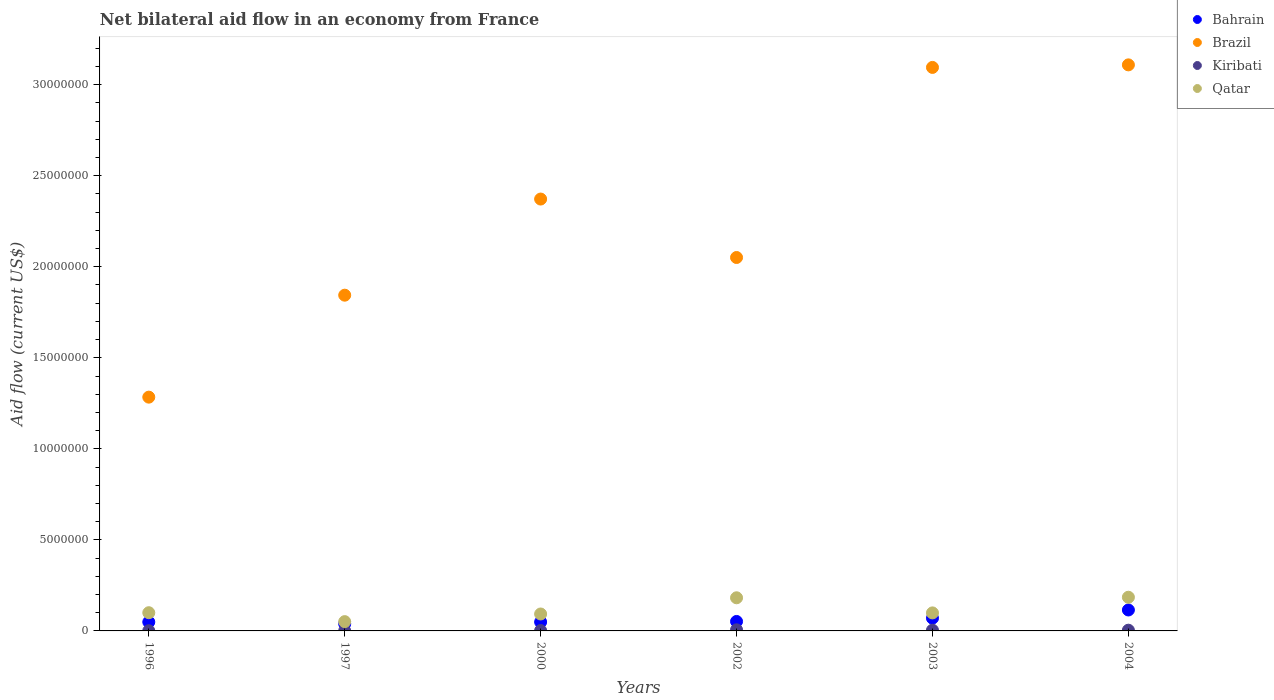Is the number of dotlines equal to the number of legend labels?
Provide a succinct answer. Yes. What is the net bilateral aid flow in Brazil in 2002?
Provide a succinct answer. 2.05e+07. Across all years, what is the maximum net bilateral aid flow in Brazil?
Provide a succinct answer. 3.11e+07. Across all years, what is the minimum net bilateral aid flow in Brazil?
Provide a short and direct response. 1.28e+07. What is the total net bilateral aid flow in Qatar in the graph?
Make the answer very short. 7.10e+06. What is the difference between the net bilateral aid flow in Qatar in 2000 and that in 2004?
Provide a succinct answer. -9.20e+05. What is the difference between the net bilateral aid flow in Kiribati in 2003 and the net bilateral aid flow in Qatar in 1997?
Make the answer very short. -4.70e+05. What is the average net bilateral aid flow in Qatar per year?
Your answer should be compact. 1.18e+06. In the year 2002, what is the difference between the net bilateral aid flow in Qatar and net bilateral aid flow in Brazil?
Provide a short and direct response. -1.87e+07. What is the ratio of the net bilateral aid flow in Qatar in 1997 to that in 2000?
Keep it short and to the point. 0.55. Is the difference between the net bilateral aid flow in Qatar in 2003 and 2004 greater than the difference between the net bilateral aid flow in Brazil in 2003 and 2004?
Offer a very short reply. No. What is the difference between the highest and the second highest net bilateral aid flow in Kiribati?
Keep it short and to the point. 2.00e+04. What is the difference between the highest and the lowest net bilateral aid flow in Qatar?
Give a very brief answer. 1.34e+06. Is the sum of the net bilateral aid flow in Brazil in 1997 and 2003 greater than the maximum net bilateral aid flow in Kiribati across all years?
Offer a terse response. Yes. Is it the case that in every year, the sum of the net bilateral aid flow in Qatar and net bilateral aid flow in Kiribati  is greater than the sum of net bilateral aid flow in Brazil and net bilateral aid flow in Bahrain?
Provide a short and direct response. No. Is it the case that in every year, the sum of the net bilateral aid flow in Kiribati and net bilateral aid flow in Qatar  is greater than the net bilateral aid flow in Brazil?
Make the answer very short. No. How many dotlines are there?
Keep it short and to the point. 4. Are the values on the major ticks of Y-axis written in scientific E-notation?
Provide a succinct answer. No. Does the graph contain grids?
Keep it short and to the point. No. What is the title of the graph?
Give a very brief answer. Net bilateral aid flow in an economy from France. Does "Uganda" appear as one of the legend labels in the graph?
Your answer should be compact. No. What is the label or title of the X-axis?
Ensure brevity in your answer.  Years. What is the Aid flow (current US$) of Brazil in 1996?
Offer a terse response. 1.28e+07. What is the Aid flow (current US$) of Kiribati in 1996?
Your answer should be compact. 10000. What is the Aid flow (current US$) in Qatar in 1996?
Make the answer very short. 1.00e+06. What is the Aid flow (current US$) in Bahrain in 1997?
Your answer should be compact. 3.90e+05. What is the Aid flow (current US$) in Brazil in 1997?
Offer a very short reply. 1.84e+07. What is the Aid flow (current US$) of Kiribati in 1997?
Provide a succinct answer. 10000. What is the Aid flow (current US$) of Qatar in 1997?
Make the answer very short. 5.10e+05. What is the Aid flow (current US$) in Brazil in 2000?
Ensure brevity in your answer.  2.37e+07. What is the Aid flow (current US$) of Qatar in 2000?
Your response must be concise. 9.30e+05. What is the Aid flow (current US$) of Bahrain in 2002?
Your response must be concise. 5.20e+05. What is the Aid flow (current US$) of Brazil in 2002?
Give a very brief answer. 2.05e+07. What is the Aid flow (current US$) of Kiribati in 2002?
Give a very brief answer. 6.00e+04. What is the Aid flow (current US$) in Qatar in 2002?
Provide a short and direct response. 1.82e+06. What is the Aid flow (current US$) in Brazil in 2003?
Give a very brief answer. 3.10e+07. What is the Aid flow (current US$) of Qatar in 2003?
Offer a very short reply. 9.90e+05. What is the Aid flow (current US$) of Bahrain in 2004?
Ensure brevity in your answer.  1.15e+06. What is the Aid flow (current US$) in Brazil in 2004?
Provide a short and direct response. 3.11e+07. What is the Aid flow (current US$) in Qatar in 2004?
Make the answer very short. 1.85e+06. Across all years, what is the maximum Aid flow (current US$) of Bahrain?
Keep it short and to the point. 1.15e+06. Across all years, what is the maximum Aid flow (current US$) of Brazil?
Provide a short and direct response. 3.11e+07. Across all years, what is the maximum Aid flow (current US$) of Qatar?
Your answer should be compact. 1.85e+06. Across all years, what is the minimum Aid flow (current US$) of Brazil?
Provide a short and direct response. 1.28e+07. Across all years, what is the minimum Aid flow (current US$) of Qatar?
Ensure brevity in your answer.  5.10e+05. What is the total Aid flow (current US$) in Bahrain in the graph?
Offer a very short reply. 3.74e+06. What is the total Aid flow (current US$) of Brazil in the graph?
Your answer should be compact. 1.38e+08. What is the total Aid flow (current US$) in Qatar in the graph?
Ensure brevity in your answer.  7.10e+06. What is the difference between the Aid flow (current US$) of Brazil in 1996 and that in 1997?
Offer a very short reply. -5.60e+06. What is the difference between the Aid flow (current US$) in Qatar in 1996 and that in 1997?
Make the answer very short. 4.90e+05. What is the difference between the Aid flow (current US$) of Bahrain in 1996 and that in 2000?
Offer a very short reply. 0. What is the difference between the Aid flow (current US$) in Brazil in 1996 and that in 2000?
Your answer should be very brief. -1.09e+07. What is the difference between the Aid flow (current US$) in Bahrain in 1996 and that in 2002?
Your answer should be very brief. -3.00e+04. What is the difference between the Aid flow (current US$) of Brazil in 1996 and that in 2002?
Provide a succinct answer. -7.67e+06. What is the difference between the Aid flow (current US$) in Qatar in 1996 and that in 2002?
Offer a terse response. -8.20e+05. What is the difference between the Aid flow (current US$) of Bahrain in 1996 and that in 2003?
Ensure brevity in your answer.  -2.10e+05. What is the difference between the Aid flow (current US$) in Brazil in 1996 and that in 2003?
Your answer should be very brief. -1.81e+07. What is the difference between the Aid flow (current US$) in Kiribati in 1996 and that in 2003?
Offer a terse response. -3.00e+04. What is the difference between the Aid flow (current US$) in Bahrain in 1996 and that in 2004?
Your answer should be compact. -6.60e+05. What is the difference between the Aid flow (current US$) of Brazil in 1996 and that in 2004?
Your answer should be compact. -1.82e+07. What is the difference between the Aid flow (current US$) of Kiribati in 1996 and that in 2004?
Ensure brevity in your answer.  -3.00e+04. What is the difference between the Aid flow (current US$) in Qatar in 1996 and that in 2004?
Your response must be concise. -8.50e+05. What is the difference between the Aid flow (current US$) of Bahrain in 1997 and that in 2000?
Keep it short and to the point. -1.00e+05. What is the difference between the Aid flow (current US$) of Brazil in 1997 and that in 2000?
Give a very brief answer. -5.28e+06. What is the difference between the Aid flow (current US$) in Qatar in 1997 and that in 2000?
Provide a short and direct response. -4.20e+05. What is the difference between the Aid flow (current US$) of Bahrain in 1997 and that in 2002?
Give a very brief answer. -1.30e+05. What is the difference between the Aid flow (current US$) of Brazil in 1997 and that in 2002?
Your answer should be very brief. -2.07e+06. What is the difference between the Aid flow (current US$) in Kiribati in 1997 and that in 2002?
Ensure brevity in your answer.  -5.00e+04. What is the difference between the Aid flow (current US$) in Qatar in 1997 and that in 2002?
Provide a short and direct response. -1.31e+06. What is the difference between the Aid flow (current US$) of Bahrain in 1997 and that in 2003?
Give a very brief answer. -3.10e+05. What is the difference between the Aid flow (current US$) in Brazil in 1997 and that in 2003?
Your answer should be compact. -1.25e+07. What is the difference between the Aid flow (current US$) in Qatar in 1997 and that in 2003?
Give a very brief answer. -4.80e+05. What is the difference between the Aid flow (current US$) of Bahrain in 1997 and that in 2004?
Make the answer very short. -7.60e+05. What is the difference between the Aid flow (current US$) in Brazil in 1997 and that in 2004?
Offer a very short reply. -1.26e+07. What is the difference between the Aid flow (current US$) of Kiribati in 1997 and that in 2004?
Give a very brief answer. -3.00e+04. What is the difference between the Aid flow (current US$) of Qatar in 1997 and that in 2004?
Offer a terse response. -1.34e+06. What is the difference between the Aid flow (current US$) of Brazil in 2000 and that in 2002?
Your answer should be compact. 3.21e+06. What is the difference between the Aid flow (current US$) in Kiribati in 2000 and that in 2002?
Ensure brevity in your answer.  -4.00e+04. What is the difference between the Aid flow (current US$) in Qatar in 2000 and that in 2002?
Offer a terse response. -8.90e+05. What is the difference between the Aid flow (current US$) of Brazil in 2000 and that in 2003?
Provide a succinct answer. -7.23e+06. What is the difference between the Aid flow (current US$) of Qatar in 2000 and that in 2003?
Keep it short and to the point. -6.00e+04. What is the difference between the Aid flow (current US$) of Bahrain in 2000 and that in 2004?
Provide a succinct answer. -6.60e+05. What is the difference between the Aid flow (current US$) in Brazil in 2000 and that in 2004?
Keep it short and to the point. -7.37e+06. What is the difference between the Aid flow (current US$) in Qatar in 2000 and that in 2004?
Provide a short and direct response. -9.20e+05. What is the difference between the Aid flow (current US$) in Brazil in 2002 and that in 2003?
Ensure brevity in your answer.  -1.04e+07. What is the difference between the Aid flow (current US$) of Qatar in 2002 and that in 2003?
Your answer should be very brief. 8.30e+05. What is the difference between the Aid flow (current US$) of Bahrain in 2002 and that in 2004?
Keep it short and to the point. -6.30e+05. What is the difference between the Aid flow (current US$) in Brazil in 2002 and that in 2004?
Make the answer very short. -1.06e+07. What is the difference between the Aid flow (current US$) of Kiribati in 2002 and that in 2004?
Provide a short and direct response. 2.00e+04. What is the difference between the Aid flow (current US$) of Bahrain in 2003 and that in 2004?
Your response must be concise. -4.50e+05. What is the difference between the Aid flow (current US$) of Brazil in 2003 and that in 2004?
Give a very brief answer. -1.40e+05. What is the difference between the Aid flow (current US$) of Kiribati in 2003 and that in 2004?
Keep it short and to the point. 0. What is the difference between the Aid flow (current US$) of Qatar in 2003 and that in 2004?
Make the answer very short. -8.60e+05. What is the difference between the Aid flow (current US$) in Bahrain in 1996 and the Aid flow (current US$) in Brazil in 1997?
Your response must be concise. -1.80e+07. What is the difference between the Aid flow (current US$) in Bahrain in 1996 and the Aid flow (current US$) in Qatar in 1997?
Ensure brevity in your answer.  -2.00e+04. What is the difference between the Aid flow (current US$) in Brazil in 1996 and the Aid flow (current US$) in Kiribati in 1997?
Offer a very short reply. 1.28e+07. What is the difference between the Aid flow (current US$) in Brazil in 1996 and the Aid flow (current US$) in Qatar in 1997?
Your response must be concise. 1.23e+07. What is the difference between the Aid flow (current US$) in Kiribati in 1996 and the Aid flow (current US$) in Qatar in 1997?
Give a very brief answer. -5.00e+05. What is the difference between the Aid flow (current US$) of Bahrain in 1996 and the Aid flow (current US$) of Brazil in 2000?
Give a very brief answer. -2.32e+07. What is the difference between the Aid flow (current US$) of Bahrain in 1996 and the Aid flow (current US$) of Kiribati in 2000?
Offer a terse response. 4.70e+05. What is the difference between the Aid flow (current US$) of Bahrain in 1996 and the Aid flow (current US$) of Qatar in 2000?
Your answer should be very brief. -4.40e+05. What is the difference between the Aid flow (current US$) of Brazil in 1996 and the Aid flow (current US$) of Kiribati in 2000?
Your answer should be compact. 1.28e+07. What is the difference between the Aid flow (current US$) of Brazil in 1996 and the Aid flow (current US$) of Qatar in 2000?
Offer a very short reply. 1.19e+07. What is the difference between the Aid flow (current US$) of Kiribati in 1996 and the Aid flow (current US$) of Qatar in 2000?
Provide a short and direct response. -9.20e+05. What is the difference between the Aid flow (current US$) in Bahrain in 1996 and the Aid flow (current US$) in Brazil in 2002?
Ensure brevity in your answer.  -2.00e+07. What is the difference between the Aid flow (current US$) of Bahrain in 1996 and the Aid flow (current US$) of Kiribati in 2002?
Provide a succinct answer. 4.30e+05. What is the difference between the Aid flow (current US$) of Bahrain in 1996 and the Aid flow (current US$) of Qatar in 2002?
Give a very brief answer. -1.33e+06. What is the difference between the Aid flow (current US$) in Brazil in 1996 and the Aid flow (current US$) in Kiribati in 2002?
Offer a very short reply. 1.28e+07. What is the difference between the Aid flow (current US$) of Brazil in 1996 and the Aid flow (current US$) of Qatar in 2002?
Keep it short and to the point. 1.10e+07. What is the difference between the Aid flow (current US$) of Kiribati in 1996 and the Aid flow (current US$) of Qatar in 2002?
Ensure brevity in your answer.  -1.81e+06. What is the difference between the Aid flow (current US$) of Bahrain in 1996 and the Aid flow (current US$) of Brazil in 2003?
Make the answer very short. -3.05e+07. What is the difference between the Aid flow (current US$) of Bahrain in 1996 and the Aid flow (current US$) of Qatar in 2003?
Offer a terse response. -5.00e+05. What is the difference between the Aid flow (current US$) in Brazil in 1996 and the Aid flow (current US$) in Kiribati in 2003?
Your response must be concise. 1.28e+07. What is the difference between the Aid flow (current US$) in Brazil in 1996 and the Aid flow (current US$) in Qatar in 2003?
Provide a short and direct response. 1.18e+07. What is the difference between the Aid flow (current US$) of Kiribati in 1996 and the Aid flow (current US$) of Qatar in 2003?
Ensure brevity in your answer.  -9.80e+05. What is the difference between the Aid flow (current US$) in Bahrain in 1996 and the Aid flow (current US$) in Brazil in 2004?
Your response must be concise. -3.06e+07. What is the difference between the Aid flow (current US$) in Bahrain in 1996 and the Aid flow (current US$) in Qatar in 2004?
Provide a short and direct response. -1.36e+06. What is the difference between the Aid flow (current US$) in Brazil in 1996 and the Aid flow (current US$) in Kiribati in 2004?
Your answer should be compact. 1.28e+07. What is the difference between the Aid flow (current US$) of Brazil in 1996 and the Aid flow (current US$) of Qatar in 2004?
Ensure brevity in your answer.  1.10e+07. What is the difference between the Aid flow (current US$) of Kiribati in 1996 and the Aid flow (current US$) of Qatar in 2004?
Offer a very short reply. -1.84e+06. What is the difference between the Aid flow (current US$) in Bahrain in 1997 and the Aid flow (current US$) in Brazil in 2000?
Your answer should be very brief. -2.33e+07. What is the difference between the Aid flow (current US$) of Bahrain in 1997 and the Aid flow (current US$) of Qatar in 2000?
Make the answer very short. -5.40e+05. What is the difference between the Aid flow (current US$) in Brazil in 1997 and the Aid flow (current US$) in Kiribati in 2000?
Your answer should be compact. 1.84e+07. What is the difference between the Aid flow (current US$) in Brazil in 1997 and the Aid flow (current US$) in Qatar in 2000?
Make the answer very short. 1.75e+07. What is the difference between the Aid flow (current US$) of Kiribati in 1997 and the Aid flow (current US$) of Qatar in 2000?
Make the answer very short. -9.20e+05. What is the difference between the Aid flow (current US$) of Bahrain in 1997 and the Aid flow (current US$) of Brazil in 2002?
Provide a short and direct response. -2.01e+07. What is the difference between the Aid flow (current US$) of Bahrain in 1997 and the Aid flow (current US$) of Qatar in 2002?
Keep it short and to the point. -1.43e+06. What is the difference between the Aid flow (current US$) of Brazil in 1997 and the Aid flow (current US$) of Kiribati in 2002?
Keep it short and to the point. 1.84e+07. What is the difference between the Aid flow (current US$) of Brazil in 1997 and the Aid flow (current US$) of Qatar in 2002?
Make the answer very short. 1.66e+07. What is the difference between the Aid flow (current US$) in Kiribati in 1997 and the Aid flow (current US$) in Qatar in 2002?
Provide a short and direct response. -1.81e+06. What is the difference between the Aid flow (current US$) of Bahrain in 1997 and the Aid flow (current US$) of Brazil in 2003?
Provide a short and direct response. -3.06e+07. What is the difference between the Aid flow (current US$) in Bahrain in 1997 and the Aid flow (current US$) in Kiribati in 2003?
Your answer should be very brief. 3.50e+05. What is the difference between the Aid flow (current US$) of Bahrain in 1997 and the Aid flow (current US$) of Qatar in 2003?
Provide a short and direct response. -6.00e+05. What is the difference between the Aid flow (current US$) of Brazil in 1997 and the Aid flow (current US$) of Kiribati in 2003?
Give a very brief answer. 1.84e+07. What is the difference between the Aid flow (current US$) in Brazil in 1997 and the Aid flow (current US$) in Qatar in 2003?
Provide a short and direct response. 1.74e+07. What is the difference between the Aid flow (current US$) of Kiribati in 1997 and the Aid flow (current US$) of Qatar in 2003?
Your answer should be very brief. -9.80e+05. What is the difference between the Aid flow (current US$) in Bahrain in 1997 and the Aid flow (current US$) in Brazil in 2004?
Offer a very short reply. -3.07e+07. What is the difference between the Aid flow (current US$) of Bahrain in 1997 and the Aid flow (current US$) of Qatar in 2004?
Make the answer very short. -1.46e+06. What is the difference between the Aid flow (current US$) of Brazil in 1997 and the Aid flow (current US$) of Kiribati in 2004?
Give a very brief answer. 1.84e+07. What is the difference between the Aid flow (current US$) in Brazil in 1997 and the Aid flow (current US$) in Qatar in 2004?
Provide a short and direct response. 1.66e+07. What is the difference between the Aid flow (current US$) in Kiribati in 1997 and the Aid flow (current US$) in Qatar in 2004?
Your answer should be very brief. -1.84e+06. What is the difference between the Aid flow (current US$) in Bahrain in 2000 and the Aid flow (current US$) in Brazil in 2002?
Give a very brief answer. -2.00e+07. What is the difference between the Aid flow (current US$) in Bahrain in 2000 and the Aid flow (current US$) in Kiribati in 2002?
Provide a short and direct response. 4.30e+05. What is the difference between the Aid flow (current US$) in Bahrain in 2000 and the Aid flow (current US$) in Qatar in 2002?
Offer a terse response. -1.33e+06. What is the difference between the Aid flow (current US$) of Brazil in 2000 and the Aid flow (current US$) of Kiribati in 2002?
Your answer should be compact. 2.37e+07. What is the difference between the Aid flow (current US$) of Brazil in 2000 and the Aid flow (current US$) of Qatar in 2002?
Your answer should be compact. 2.19e+07. What is the difference between the Aid flow (current US$) of Kiribati in 2000 and the Aid flow (current US$) of Qatar in 2002?
Ensure brevity in your answer.  -1.80e+06. What is the difference between the Aid flow (current US$) in Bahrain in 2000 and the Aid flow (current US$) in Brazil in 2003?
Give a very brief answer. -3.05e+07. What is the difference between the Aid flow (current US$) of Bahrain in 2000 and the Aid flow (current US$) of Kiribati in 2003?
Provide a short and direct response. 4.50e+05. What is the difference between the Aid flow (current US$) in Bahrain in 2000 and the Aid flow (current US$) in Qatar in 2003?
Offer a terse response. -5.00e+05. What is the difference between the Aid flow (current US$) of Brazil in 2000 and the Aid flow (current US$) of Kiribati in 2003?
Keep it short and to the point. 2.37e+07. What is the difference between the Aid flow (current US$) in Brazil in 2000 and the Aid flow (current US$) in Qatar in 2003?
Ensure brevity in your answer.  2.27e+07. What is the difference between the Aid flow (current US$) in Kiribati in 2000 and the Aid flow (current US$) in Qatar in 2003?
Your answer should be compact. -9.70e+05. What is the difference between the Aid flow (current US$) in Bahrain in 2000 and the Aid flow (current US$) in Brazil in 2004?
Provide a short and direct response. -3.06e+07. What is the difference between the Aid flow (current US$) of Bahrain in 2000 and the Aid flow (current US$) of Qatar in 2004?
Your answer should be compact. -1.36e+06. What is the difference between the Aid flow (current US$) of Brazil in 2000 and the Aid flow (current US$) of Kiribati in 2004?
Offer a terse response. 2.37e+07. What is the difference between the Aid flow (current US$) in Brazil in 2000 and the Aid flow (current US$) in Qatar in 2004?
Your response must be concise. 2.19e+07. What is the difference between the Aid flow (current US$) of Kiribati in 2000 and the Aid flow (current US$) of Qatar in 2004?
Your answer should be very brief. -1.83e+06. What is the difference between the Aid flow (current US$) of Bahrain in 2002 and the Aid flow (current US$) of Brazil in 2003?
Provide a short and direct response. -3.04e+07. What is the difference between the Aid flow (current US$) of Bahrain in 2002 and the Aid flow (current US$) of Qatar in 2003?
Provide a succinct answer. -4.70e+05. What is the difference between the Aid flow (current US$) of Brazil in 2002 and the Aid flow (current US$) of Kiribati in 2003?
Offer a very short reply. 2.05e+07. What is the difference between the Aid flow (current US$) of Brazil in 2002 and the Aid flow (current US$) of Qatar in 2003?
Keep it short and to the point. 1.95e+07. What is the difference between the Aid flow (current US$) in Kiribati in 2002 and the Aid flow (current US$) in Qatar in 2003?
Offer a very short reply. -9.30e+05. What is the difference between the Aid flow (current US$) of Bahrain in 2002 and the Aid flow (current US$) of Brazil in 2004?
Keep it short and to the point. -3.06e+07. What is the difference between the Aid flow (current US$) of Bahrain in 2002 and the Aid flow (current US$) of Qatar in 2004?
Provide a short and direct response. -1.33e+06. What is the difference between the Aid flow (current US$) in Brazil in 2002 and the Aid flow (current US$) in Kiribati in 2004?
Your answer should be very brief. 2.05e+07. What is the difference between the Aid flow (current US$) in Brazil in 2002 and the Aid flow (current US$) in Qatar in 2004?
Offer a terse response. 1.87e+07. What is the difference between the Aid flow (current US$) of Kiribati in 2002 and the Aid flow (current US$) of Qatar in 2004?
Offer a terse response. -1.79e+06. What is the difference between the Aid flow (current US$) of Bahrain in 2003 and the Aid flow (current US$) of Brazil in 2004?
Your response must be concise. -3.04e+07. What is the difference between the Aid flow (current US$) in Bahrain in 2003 and the Aid flow (current US$) in Kiribati in 2004?
Give a very brief answer. 6.60e+05. What is the difference between the Aid flow (current US$) in Bahrain in 2003 and the Aid flow (current US$) in Qatar in 2004?
Ensure brevity in your answer.  -1.15e+06. What is the difference between the Aid flow (current US$) of Brazil in 2003 and the Aid flow (current US$) of Kiribati in 2004?
Your answer should be compact. 3.09e+07. What is the difference between the Aid flow (current US$) of Brazil in 2003 and the Aid flow (current US$) of Qatar in 2004?
Give a very brief answer. 2.91e+07. What is the difference between the Aid flow (current US$) in Kiribati in 2003 and the Aid flow (current US$) in Qatar in 2004?
Make the answer very short. -1.81e+06. What is the average Aid flow (current US$) in Bahrain per year?
Your answer should be compact. 6.23e+05. What is the average Aid flow (current US$) in Brazil per year?
Provide a short and direct response. 2.29e+07. What is the average Aid flow (current US$) in Qatar per year?
Ensure brevity in your answer.  1.18e+06. In the year 1996, what is the difference between the Aid flow (current US$) in Bahrain and Aid flow (current US$) in Brazil?
Give a very brief answer. -1.24e+07. In the year 1996, what is the difference between the Aid flow (current US$) in Bahrain and Aid flow (current US$) in Qatar?
Offer a terse response. -5.10e+05. In the year 1996, what is the difference between the Aid flow (current US$) of Brazil and Aid flow (current US$) of Kiribati?
Give a very brief answer. 1.28e+07. In the year 1996, what is the difference between the Aid flow (current US$) in Brazil and Aid flow (current US$) in Qatar?
Your answer should be compact. 1.18e+07. In the year 1996, what is the difference between the Aid flow (current US$) of Kiribati and Aid flow (current US$) of Qatar?
Your response must be concise. -9.90e+05. In the year 1997, what is the difference between the Aid flow (current US$) of Bahrain and Aid flow (current US$) of Brazil?
Give a very brief answer. -1.80e+07. In the year 1997, what is the difference between the Aid flow (current US$) of Bahrain and Aid flow (current US$) of Kiribati?
Give a very brief answer. 3.80e+05. In the year 1997, what is the difference between the Aid flow (current US$) in Brazil and Aid flow (current US$) in Kiribati?
Ensure brevity in your answer.  1.84e+07. In the year 1997, what is the difference between the Aid flow (current US$) in Brazil and Aid flow (current US$) in Qatar?
Provide a succinct answer. 1.79e+07. In the year 1997, what is the difference between the Aid flow (current US$) in Kiribati and Aid flow (current US$) in Qatar?
Make the answer very short. -5.00e+05. In the year 2000, what is the difference between the Aid flow (current US$) in Bahrain and Aid flow (current US$) in Brazil?
Offer a terse response. -2.32e+07. In the year 2000, what is the difference between the Aid flow (current US$) in Bahrain and Aid flow (current US$) in Kiribati?
Make the answer very short. 4.70e+05. In the year 2000, what is the difference between the Aid flow (current US$) in Bahrain and Aid flow (current US$) in Qatar?
Ensure brevity in your answer.  -4.40e+05. In the year 2000, what is the difference between the Aid flow (current US$) in Brazil and Aid flow (current US$) in Kiribati?
Ensure brevity in your answer.  2.37e+07. In the year 2000, what is the difference between the Aid flow (current US$) of Brazil and Aid flow (current US$) of Qatar?
Provide a succinct answer. 2.28e+07. In the year 2000, what is the difference between the Aid flow (current US$) in Kiribati and Aid flow (current US$) in Qatar?
Provide a succinct answer. -9.10e+05. In the year 2002, what is the difference between the Aid flow (current US$) in Bahrain and Aid flow (current US$) in Brazil?
Offer a very short reply. -2.00e+07. In the year 2002, what is the difference between the Aid flow (current US$) in Bahrain and Aid flow (current US$) in Qatar?
Ensure brevity in your answer.  -1.30e+06. In the year 2002, what is the difference between the Aid flow (current US$) of Brazil and Aid flow (current US$) of Kiribati?
Make the answer very short. 2.04e+07. In the year 2002, what is the difference between the Aid flow (current US$) of Brazil and Aid flow (current US$) of Qatar?
Provide a succinct answer. 1.87e+07. In the year 2002, what is the difference between the Aid flow (current US$) of Kiribati and Aid flow (current US$) of Qatar?
Offer a terse response. -1.76e+06. In the year 2003, what is the difference between the Aid flow (current US$) in Bahrain and Aid flow (current US$) in Brazil?
Keep it short and to the point. -3.02e+07. In the year 2003, what is the difference between the Aid flow (current US$) in Bahrain and Aid flow (current US$) in Qatar?
Offer a terse response. -2.90e+05. In the year 2003, what is the difference between the Aid flow (current US$) in Brazil and Aid flow (current US$) in Kiribati?
Keep it short and to the point. 3.09e+07. In the year 2003, what is the difference between the Aid flow (current US$) of Brazil and Aid flow (current US$) of Qatar?
Your answer should be very brief. 3.00e+07. In the year 2003, what is the difference between the Aid flow (current US$) in Kiribati and Aid flow (current US$) in Qatar?
Ensure brevity in your answer.  -9.50e+05. In the year 2004, what is the difference between the Aid flow (current US$) in Bahrain and Aid flow (current US$) in Brazil?
Offer a terse response. -2.99e+07. In the year 2004, what is the difference between the Aid flow (current US$) in Bahrain and Aid flow (current US$) in Kiribati?
Ensure brevity in your answer.  1.11e+06. In the year 2004, what is the difference between the Aid flow (current US$) in Bahrain and Aid flow (current US$) in Qatar?
Offer a very short reply. -7.00e+05. In the year 2004, what is the difference between the Aid flow (current US$) of Brazil and Aid flow (current US$) of Kiribati?
Give a very brief answer. 3.10e+07. In the year 2004, what is the difference between the Aid flow (current US$) in Brazil and Aid flow (current US$) in Qatar?
Your answer should be compact. 2.92e+07. In the year 2004, what is the difference between the Aid flow (current US$) of Kiribati and Aid flow (current US$) of Qatar?
Your answer should be compact. -1.81e+06. What is the ratio of the Aid flow (current US$) in Bahrain in 1996 to that in 1997?
Offer a terse response. 1.26. What is the ratio of the Aid flow (current US$) in Brazil in 1996 to that in 1997?
Offer a terse response. 0.7. What is the ratio of the Aid flow (current US$) of Kiribati in 1996 to that in 1997?
Provide a succinct answer. 1. What is the ratio of the Aid flow (current US$) in Qatar in 1996 to that in 1997?
Your response must be concise. 1.96. What is the ratio of the Aid flow (current US$) of Bahrain in 1996 to that in 2000?
Your answer should be very brief. 1. What is the ratio of the Aid flow (current US$) of Brazil in 1996 to that in 2000?
Keep it short and to the point. 0.54. What is the ratio of the Aid flow (current US$) of Kiribati in 1996 to that in 2000?
Give a very brief answer. 0.5. What is the ratio of the Aid flow (current US$) in Qatar in 1996 to that in 2000?
Provide a short and direct response. 1.08. What is the ratio of the Aid flow (current US$) of Bahrain in 1996 to that in 2002?
Offer a terse response. 0.94. What is the ratio of the Aid flow (current US$) of Brazil in 1996 to that in 2002?
Provide a succinct answer. 0.63. What is the ratio of the Aid flow (current US$) of Kiribati in 1996 to that in 2002?
Offer a very short reply. 0.17. What is the ratio of the Aid flow (current US$) in Qatar in 1996 to that in 2002?
Keep it short and to the point. 0.55. What is the ratio of the Aid flow (current US$) in Brazil in 1996 to that in 2003?
Your answer should be very brief. 0.41. What is the ratio of the Aid flow (current US$) of Kiribati in 1996 to that in 2003?
Ensure brevity in your answer.  0.25. What is the ratio of the Aid flow (current US$) in Qatar in 1996 to that in 2003?
Offer a very short reply. 1.01. What is the ratio of the Aid flow (current US$) in Bahrain in 1996 to that in 2004?
Keep it short and to the point. 0.43. What is the ratio of the Aid flow (current US$) of Brazil in 1996 to that in 2004?
Provide a short and direct response. 0.41. What is the ratio of the Aid flow (current US$) of Qatar in 1996 to that in 2004?
Your answer should be very brief. 0.54. What is the ratio of the Aid flow (current US$) in Bahrain in 1997 to that in 2000?
Ensure brevity in your answer.  0.8. What is the ratio of the Aid flow (current US$) in Brazil in 1997 to that in 2000?
Provide a short and direct response. 0.78. What is the ratio of the Aid flow (current US$) of Qatar in 1997 to that in 2000?
Make the answer very short. 0.55. What is the ratio of the Aid flow (current US$) of Brazil in 1997 to that in 2002?
Offer a terse response. 0.9. What is the ratio of the Aid flow (current US$) in Kiribati in 1997 to that in 2002?
Offer a terse response. 0.17. What is the ratio of the Aid flow (current US$) in Qatar in 1997 to that in 2002?
Your answer should be compact. 0.28. What is the ratio of the Aid flow (current US$) in Bahrain in 1997 to that in 2003?
Provide a short and direct response. 0.56. What is the ratio of the Aid flow (current US$) of Brazil in 1997 to that in 2003?
Ensure brevity in your answer.  0.6. What is the ratio of the Aid flow (current US$) in Kiribati in 1997 to that in 2003?
Offer a terse response. 0.25. What is the ratio of the Aid flow (current US$) in Qatar in 1997 to that in 2003?
Provide a short and direct response. 0.52. What is the ratio of the Aid flow (current US$) in Bahrain in 1997 to that in 2004?
Offer a very short reply. 0.34. What is the ratio of the Aid flow (current US$) in Brazil in 1997 to that in 2004?
Keep it short and to the point. 0.59. What is the ratio of the Aid flow (current US$) in Kiribati in 1997 to that in 2004?
Provide a short and direct response. 0.25. What is the ratio of the Aid flow (current US$) of Qatar in 1997 to that in 2004?
Make the answer very short. 0.28. What is the ratio of the Aid flow (current US$) in Bahrain in 2000 to that in 2002?
Offer a terse response. 0.94. What is the ratio of the Aid flow (current US$) in Brazil in 2000 to that in 2002?
Your answer should be very brief. 1.16. What is the ratio of the Aid flow (current US$) in Qatar in 2000 to that in 2002?
Your answer should be compact. 0.51. What is the ratio of the Aid flow (current US$) of Bahrain in 2000 to that in 2003?
Your answer should be compact. 0.7. What is the ratio of the Aid flow (current US$) in Brazil in 2000 to that in 2003?
Provide a short and direct response. 0.77. What is the ratio of the Aid flow (current US$) of Kiribati in 2000 to that in 2003?
Offer a very short reply. 0.5. What is the ratio of the Aid flow (current US$) of Qatar in 2000 to that in 2003?
Provide a succinct answer. 0.94. What is the ratio of the Aid flow (current US$) in Bahrain in 2000 to that in 2004?
Offer a very short reply. 0.43. What is the ratio of the Aid flow (current US$) in Brazil in 2000 to that in 2004?
Offer a very short reply. 0.76. What is the ratio of the Aid flow (current US$) in Kiribati in 2000 to that in 2004?
Your answer should be very brief. 0.5. What is the ratio of the Aid flow (current US$) in Qatar in 2000 to that in 2004?
Provide a succinct answer. 0.5. What is the ratio of the Aid flow (current US$) in Bahrain in 2002 to that in 2003?
Your answer should be compact. 0.74. What is the ratio of the Aid flow (current US$) in Brazil in 2002 to that in 2003?
Provide a succinct answer. 0.66. What is the ratio of the Aid flow (current US$) in Qatar in 2002 to that in 2003?
Your response must be concise. 1.84. What is the ratio of the Aid flow (current US$) of Bahrain in 2002 to that in 2004?
Your answer should be compact. 0.45. What is the ratio of the Aid flow (current US$) in Brazil in 2002 to that in 2004?
Offer a terse response. 0.66. What is the ratio of the Aid flow (current US$) in Qatar in 2002 to that in 2004?
Provide a succinct answer. 0.98. What is the ratio of the Aid flow (current US$) of Bahrain in 2003 to that in 2004?
Ensure brevity in your answer.  0.61. What is the ratio of the Aid flow (current US$) in Brazil in 2003 to that in 2004?
Keep it short and to the point. 1. What is the ratio of the Aid flow (current US$) of Kiribati in 2003 to that in 2004?
Make the answer very short. 1. What is the ratio of the Aid flow (current US$) of Qatar in 2003 to that in 2004?
Give a very brief answer. 0.54. What is the difference between the highest and the second highest Aid flow (current US$) in Bahrain?
Provide a short and direct response. 4.50e+05. What is the difference between the highest and the second highest Aid flow (current US$) in Kiribati?
Provide a short and direct response. 2.00e+04. What is the difference between the highest and the lowest Aid flow (current US$) in Bahrain?
Provide a succinct answer. 7.60e+05. What is the difference between the highest and the lowest Aid flow (current US$) in Brazil?
Make the answer very short. 1.82e+07. What is the difference between the highest and the lowest Aid flow (current US$) of Qatar?
Ensure brevity in your answer.  1.34e+06. 